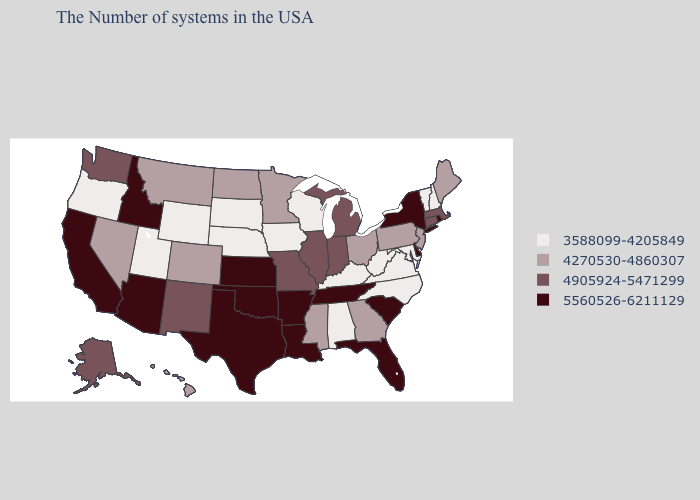What is the value of Alabama?
Answer briefly. 3588099-4205849. What is the value of Missouri?
Keep it brief. 4905924-5471299. Does Kansas have the highest value in the MidWest?
Keep it brief. Yes. What is the value of Kentucky?
Write a very short answer. 3588099-4205849. Which states have the highest value in the USA?
Be succinct. Rhode Island, New York, Delaware, South Carolina, Florida, Tennessee, Louisiana, Arkansas, Kansas, Oklahoma, Texas, Arizona, Idaho, California. What is the highest value in the MidWest ?
Be succinct. 5560526-6211129. What is the value of Maine?
Give a very brief answer. 4270530-4860307. Name the states that have a value in the range 3588099-4205849?
Write a very short answer. New Hampshire, Vermont, Maryland, Virginia, North Carolina, West Virginia, Kentucky, Alabama, Wisconsin, Iowa, Nebraska, South Dakota, Wyoming, Utah, Oregon. Does the first symbol in the legend represent the smallest category?
Answer briefly. Yes. Does Maryland have the same value as Minnesota?
Answer briefly. No. Which states have the lowest value in the USA?
Concise answer only. New Hampshire, Vermont, Maryland, Virginia, North Carolina, West Virginia, Kentucky, Alabama, Wisconsin, Iowa, Nebraska, South Dakota, Wyoming, Utah, Oregon. Which states have the lowest value in the USA?
Quick response, please. New Hampshire, Vermont, Maryland, Virginia, North Carolina, West Virginia, Kentucky, Alabama, Wisconsin, Iowa, Nebraska, South Dakota, Wyoming, Utah, Oregon. Name the states that have a value in the range 4905924-5471299?
Quick response, please. Massachusetts, Connecticut, Michigan, Indiana, Illinois, Missouri, New Mexico, Washington, Alaska. Among the states that border North Dakota , which have the highest value?
Quick response, please. Minnesota, Montana. 